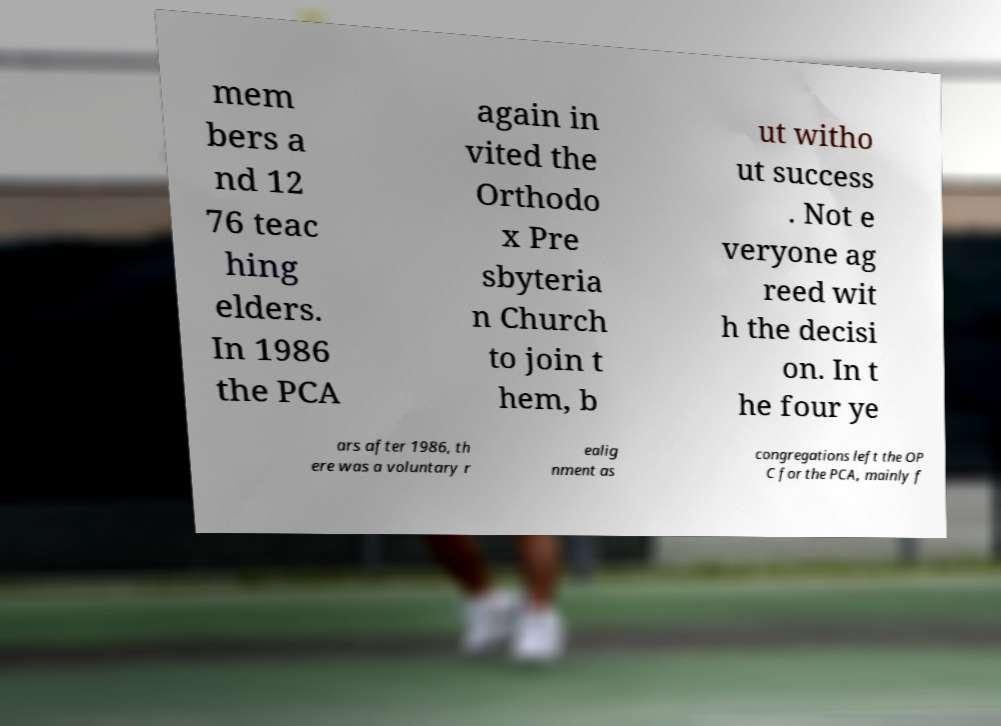Can you read and provide the text displayed in the image?This photo seems to have some interesting text. Can you extract and type it out for me? mem bers a nd 12 76 teac hing elders. In 1986 the PCA again in vited the Orthodo x Pre sbyteria n Church to join t hem, b ut witho ut success . Not e veryone ag reed wit h the decisi on. In t he four ye ars after 1986, th ere was a voluntary r ealig nment as congregations left the OP C for the PCA, mainly f 